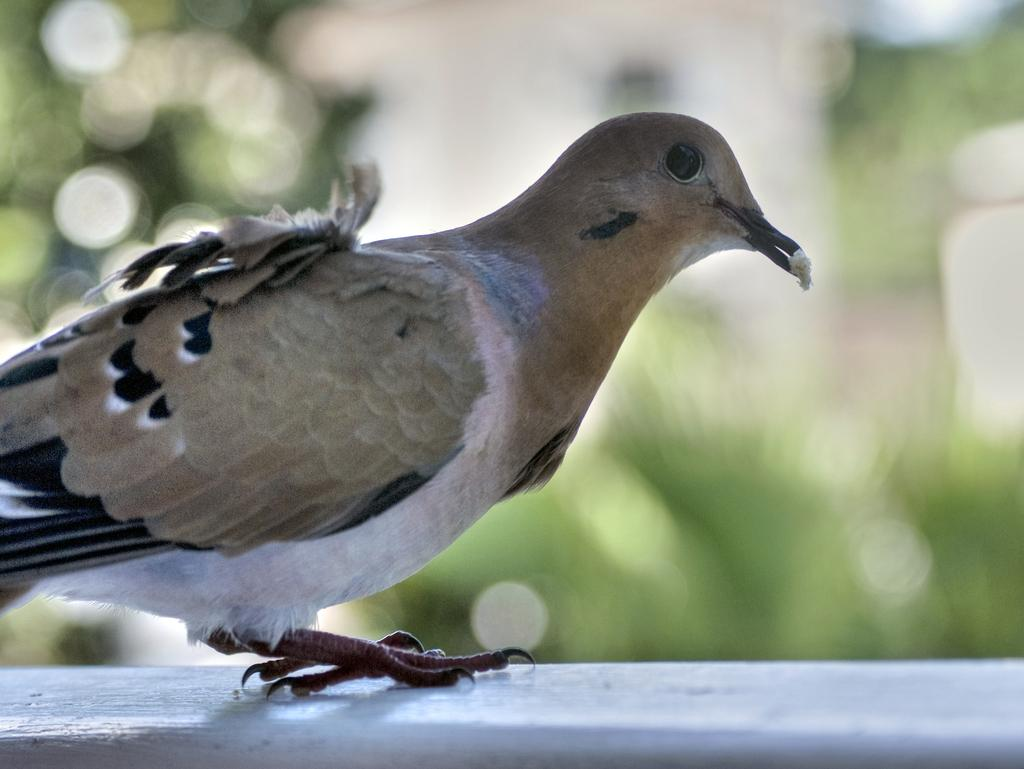What type of animal is present in the image? There is a bird in the image. Where is the bird located? The bird is on a surface that resembles a wall. Can you describe the background of the image? The background of the image is blurred. What crime is the bird committing in the image? There is no crime being committed in the image; it is a bird on a wall. What time of day is depicted in the image? The time of day is not mentioned or depicted in the image. 